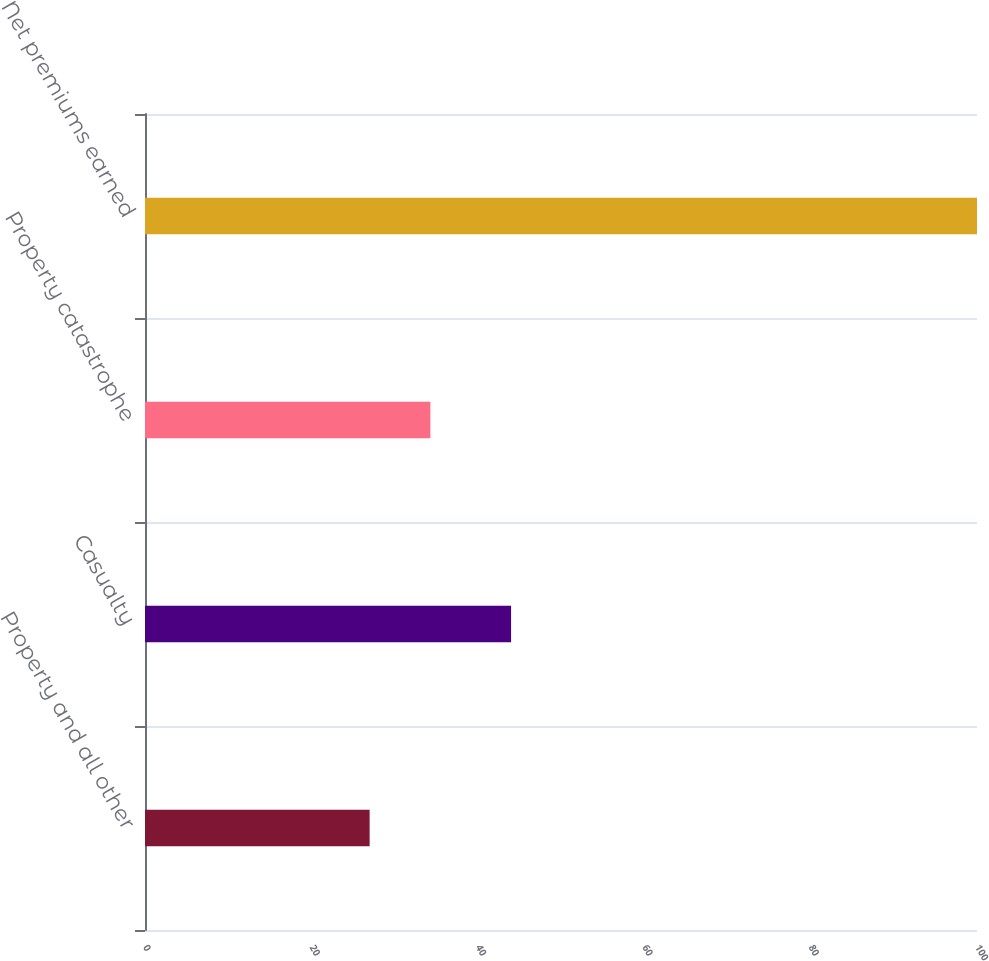Convert chart to OTSL. <chart><loc_0><loc_0><loc_500><loc_500><bar_chart><fcel>Property and all other<fcel>Casualty<fcel>Property catastrophe<fcel>Net premiums earned<nl><fcel>27<fcel>44<fcel>34.3<fcel>100<nl></chart> 